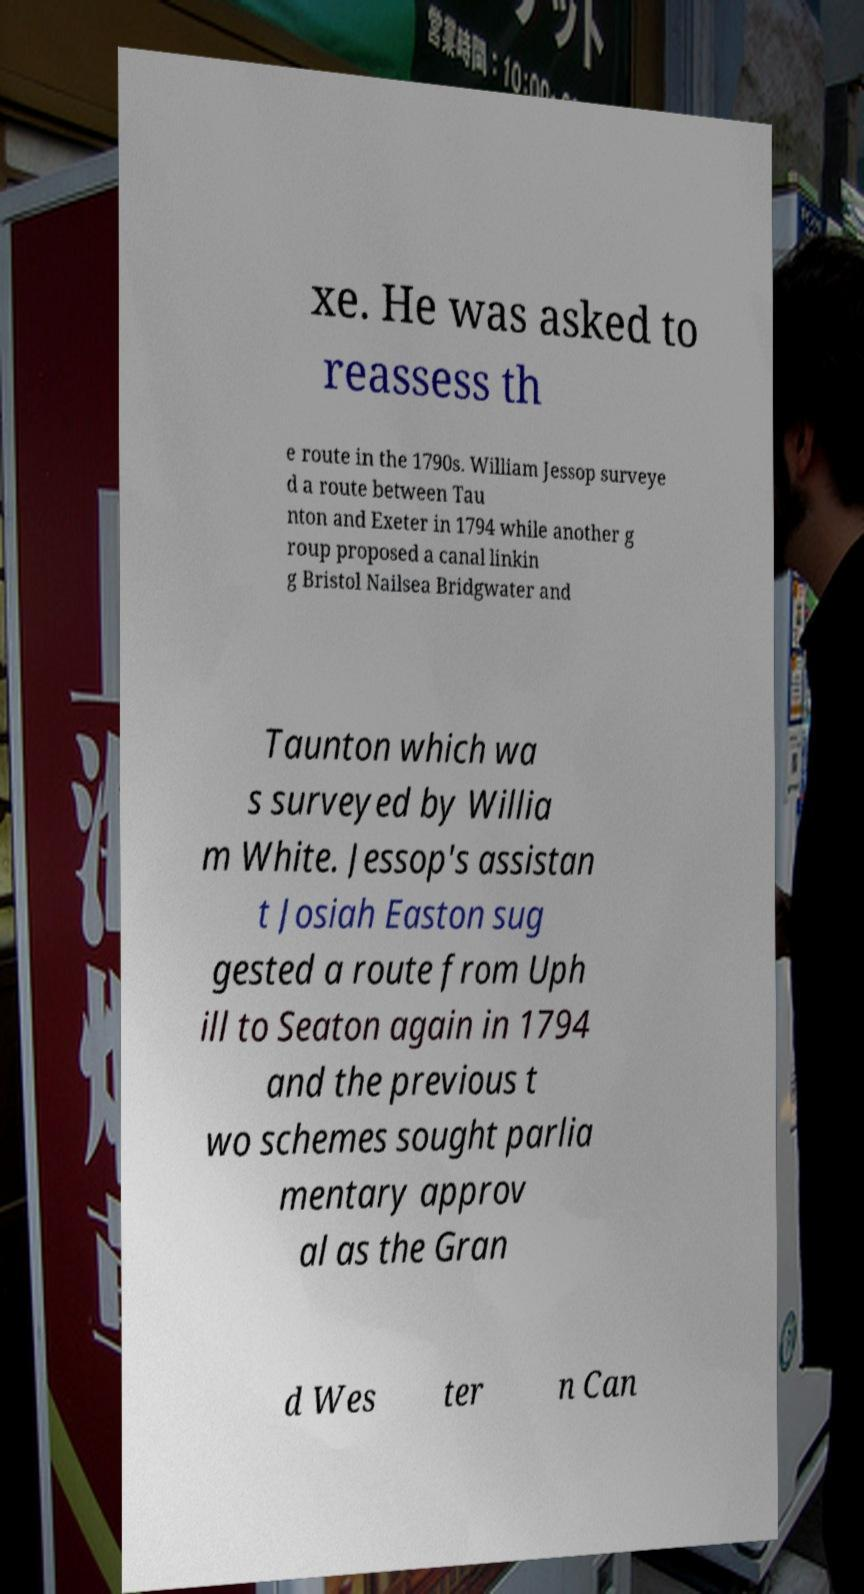Please read and relay the text visible in this image. What does it say? xe. He was asked to reassess th e route in the 1790s. William Jessop surveye d a route between Tau nton and Exeter in 1794 while another g roup proposed a canal linkin g Bristol Nailsea Bridgwater and Taunton which wa s surveyed by Willia m White. Jessop's assistan t Josiah Easton sug gested a route from Uph ill to Seaton again in 1794 and the previous t wo schemes sought parlia mentary approv al as the Gran d Wes ter n Can 